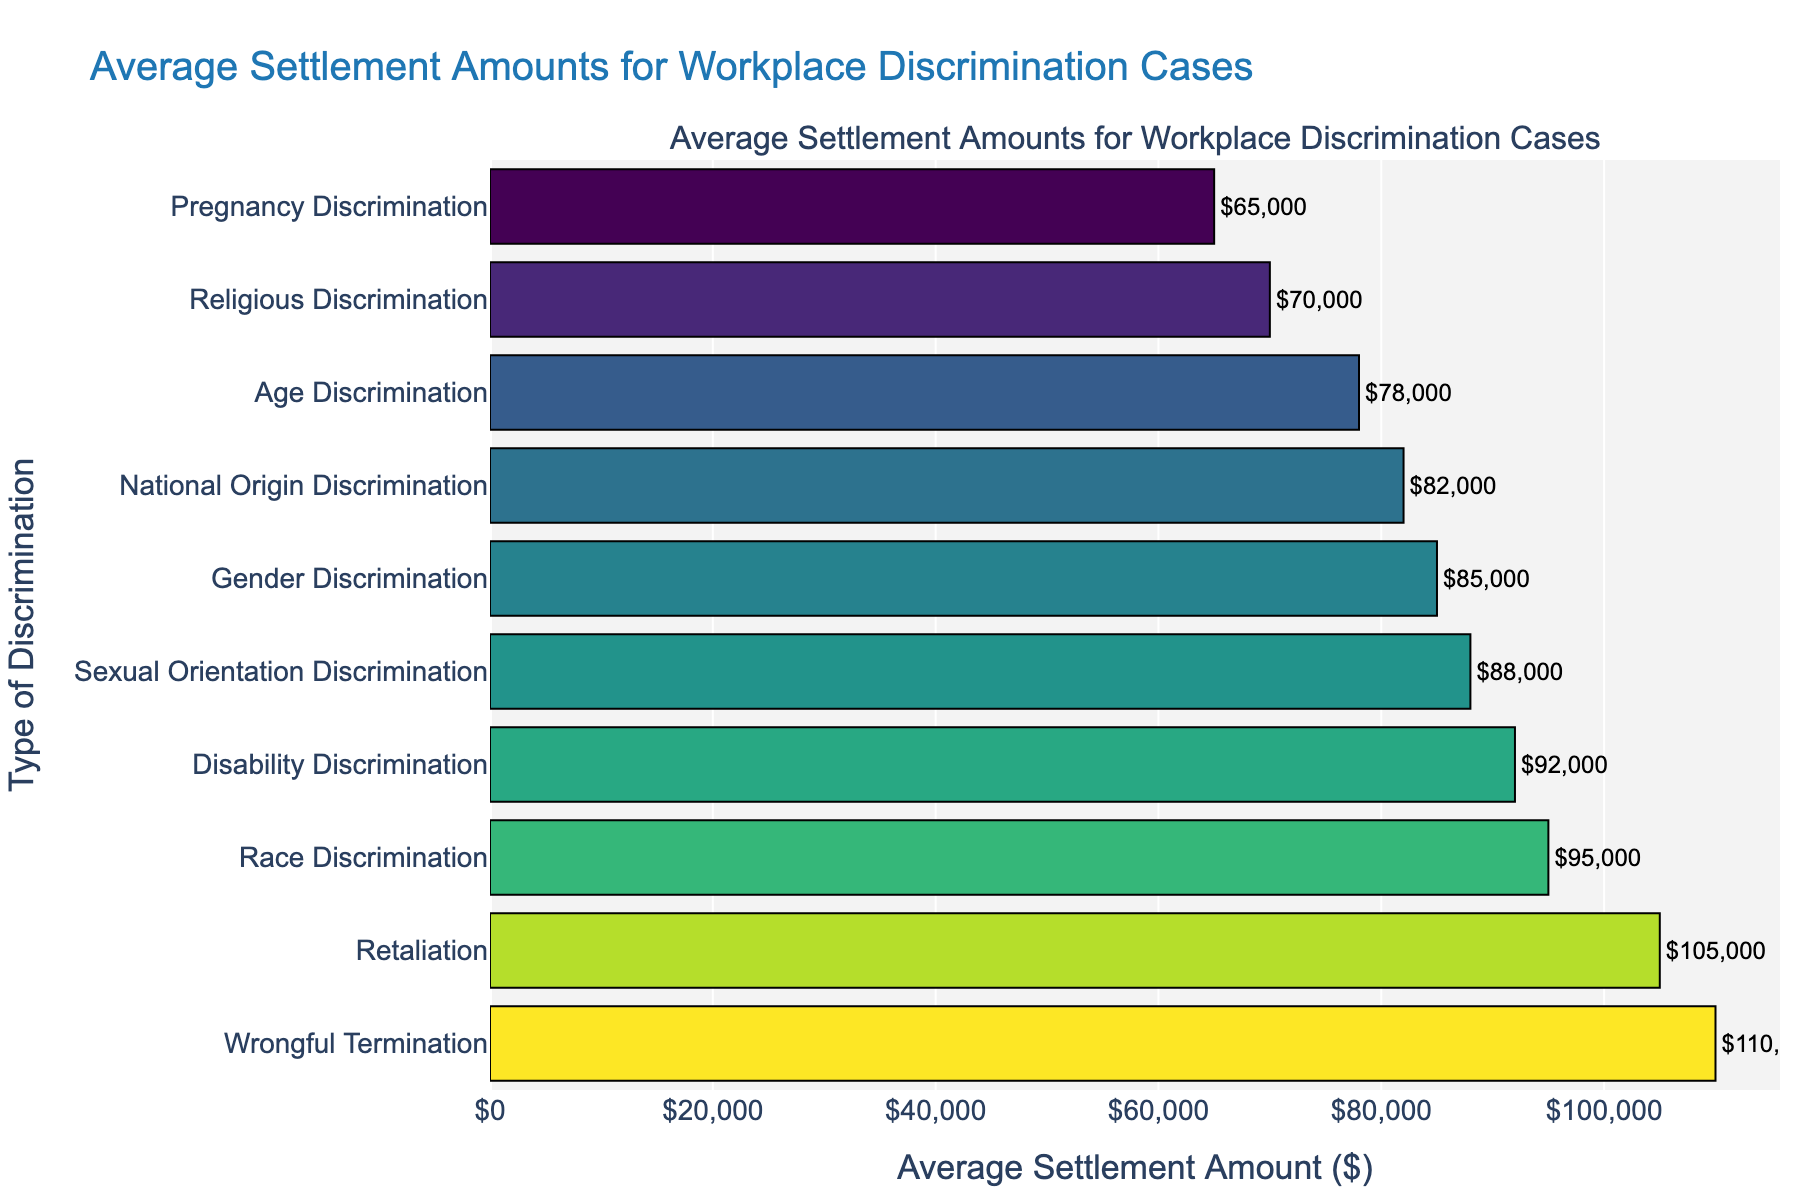What's the average settlement amount for Race Discrimination? The chart shows a bar for Race Discrimination labeled with the settlement amount. It states $95,000.
Answer: $95,000 Which type of discrimination has the highest average settlement amount? The bar for Wrongful Termination is the longest and labeled with $110,000, indicating it has the highest average settlement amount.
Answer: Wrongful Termination How much more is the average settlement for Retaliation compared to Religious Discrimination? The settlement amounts are $105,000 for Retaliation and $70,000 for Religious Discrimination. The difference is $105,000 - $70,000 = $35,000.
Answer: $35,000 Which types of discrimination have an average settlement amount greater than $90,000? The chart shows bars for Race Discrimination ($95,000), Disability Discrimination ($92,000), Retaliation ($105,000), and Wrongful Termination ($110,000) exceeding $90,000.
Answer: Race Discrimination, Disability Discrimination, Retaliation, Wrongful Termination What is the total average settlement amount for Gender Discrimination, National Origin Discrimination, and Sexual Orientation Discrimination? Add the settlement amounts: $85,000 (Gender Discrimination) + $82,000 (National Origin Discrimination) + $88,000 (Sexual Orientation Discrimination) = $255,000.
Answer: $255,000 What is the difference in average settlement amounts between Race Discrimination and Age Discrimination? The settlement amount for Race Discrimination is $95,000, and for Age Discrimination, it is $78,000. The difference is $95,000 - $78,000 = $17,000.
Answer: $17,000 Which type of discrimination has the lowest average settlement amount? The bar for Pregnancy Discrimination is the shortest and labeled with $65,000, indicating it has the lowest average settlement amount.
Answer: Pregnancy Discrimination How many types of discrimination have an average settlement amount between $70,000 and $90,000? The chart shows bars within this range for Gender Discrimination ($85,000), Age Discrimination ($78,000), National Origin Discrimination ($82,000), Religious Discrimination ($70,000), and Sexual Orientation Discrimination ($88,000). This makes 5 types.
Answer: 5 types Is the average settlement amount for Disability Discrimination greater than for Sexual Orientation Discrimination? Comparing the amounts, $92,000 (Disability Discrimination) is greater than $88,000 (Sexual Orientation Discrimination).
Answer: Yes What is the average settlement amount for the first five types of discrimination listed in descending order? The first five types listed in descending order are Wrongful Termination ($110,000), Retaliation ($105,000), Race Discrimination ($95,000), Disability Discrimination ($92,000), and Sexual Orientation Discrimination ($88,000). The average is calculated as ($110,000 + $105,000 + $95,000 + $92,000 + $88,000) / 5 = $98,000.
Answer: $98,000 